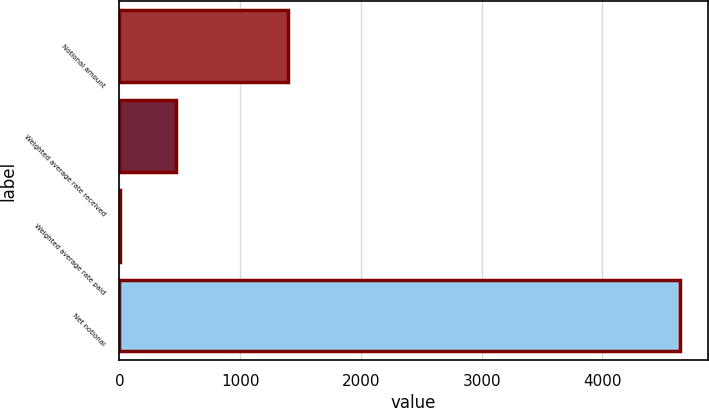Convert chart to OTSL. <chart><loc_0><loc_0><loc_500><loc_500><bar_chart><fcel>Notional amount<fcel>Weighted average rate received<fcel>Weighted average rate paid<fcel>Net notional<nl><fcel>1400<fcel>468.16<fcel>4.62<fcel>4640<nl></chart> 